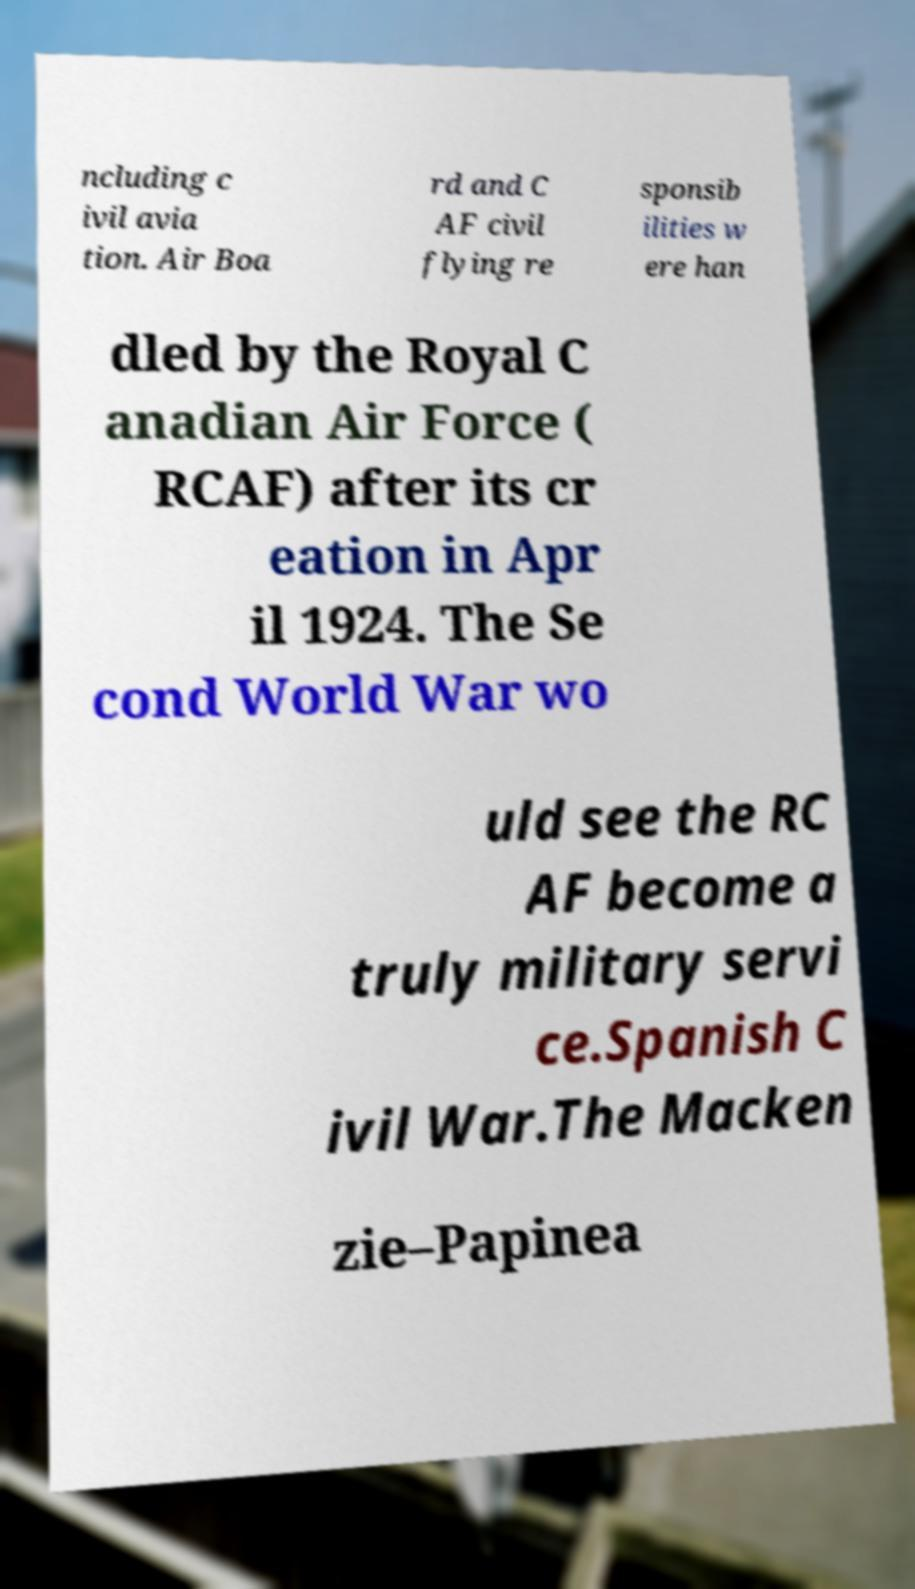For documentation purposes, I need the text within this image transcribed. Could you provide that? ncluding c ivil avia tion. Air Boa rd and C AF civil flying re sponsib ilities w ere han dled by the Royal C anadian Air Force ( RCAF) after its cr eation in Apr il 1924. The Se cond World War wo uld see the RC AF become a truly military servi ce.Spanish C ivil War.The Macken zie–Papinea 